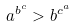<formula> <loc_0><loc_0><loc_500><loc_500>a ^ { b ^ { c } } > b ^ { c ^ { a } }</formula> 